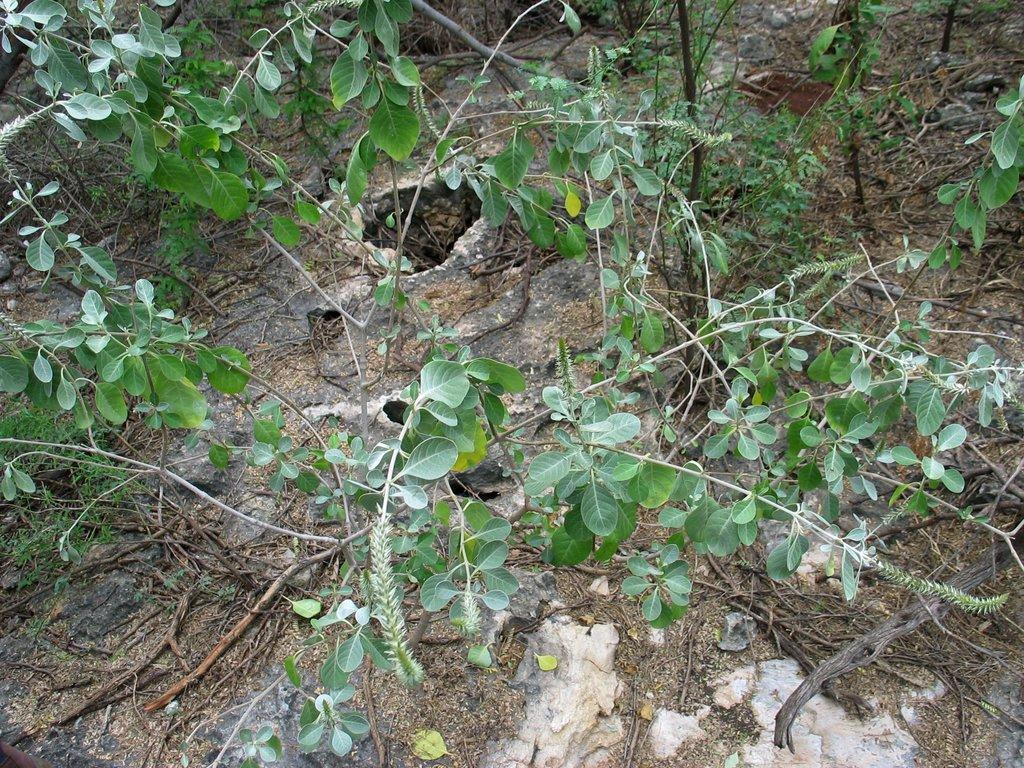Can you describe this image briefly? In this picture I can see the plants. At the bottom I can see the sticks and dust. On the left I can see the green leaves. 